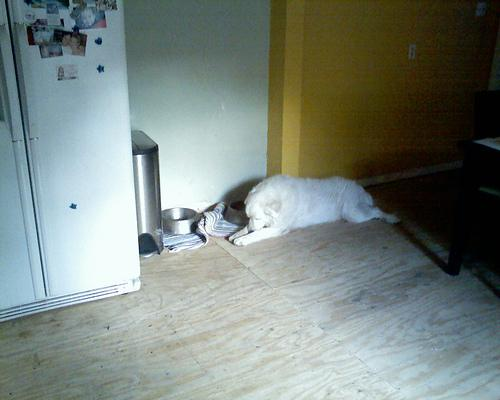Question: what kind of animal is in the picture?
Choices:
A. Cow.
B. A dog.
C. Pig.
D. Cat.
Answer with the letter. Answer: B Question: what kind of floor is in the picture?
Choices:
A. Tile.
B. Laminate.
C. Wood.
D. Concrete.
Answer with the letter. Answer: C Question: what is sitting next to the fridge?
Choices:
A. A trash can.
B. A bucket.
C. Bag of groceries.
D. The stove.
Answer with the letter. Answer: A Question: how many doors are on the fridge?
Choices:
A. Three.
B. Four.
C. Two.
D. Five.
Answer with the letter. Answer: C 